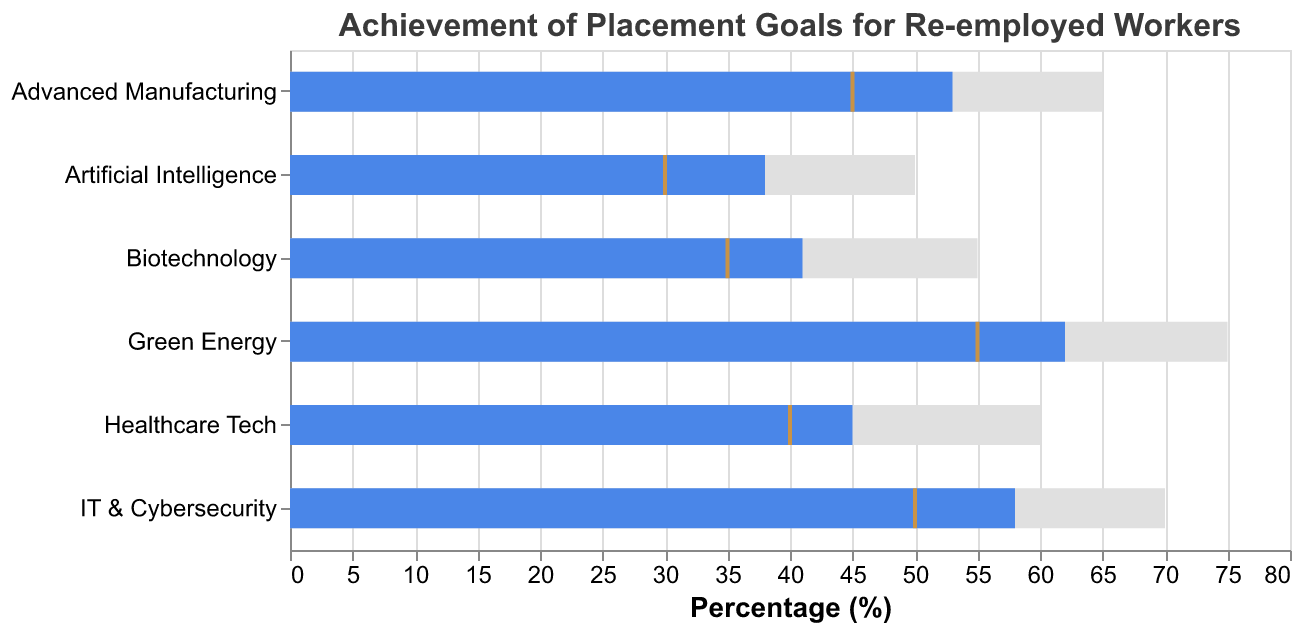By how many percent does the actual placement percentage for IT & Cybersecurity fall short of its target? Subtract the actual placement percentage from the target placement percentage for IT & Cybersecurity. Target is 70%, and Actual is 58%, so the shortfall is 70 - 58.
Answer: 12% What industries have met their benchmarks in placement goals? Industries that have their 'Actual' bars equal to or exceed the 'Benchmark' ticks meet their benchmarks.
Answer: Green Energy, IT & Cybersecurity, Advanced Manufacturing Which industry has the lowest benchmark placement percentage? Look for the industry with the lowest tick mark on the chart, which represents the benchmark.
Answer: Artificial Intelligence Compare the actual placement percentages of Advanced Manufacturing and Biotechnology. Which one is higher? Compare the lengths of the 'Actual' bars for both Advanced Manufacturing and Biotechnology.
Answer: Advanced Manufacturing What is the difference between the target and benchmark placement percentages for Artificial Intelligence? Subtract the benchmark percentage from the target percentage. Target is 50%, Benchmark is 30%, so the difference is 50 - 30.
Answer: 20% Which industries have exceeded their benchmark placement percentages but not reached their target percentages? Industries where the 'Actual' bar is higher than the benchmark tick but lower than the target bar are the ones.
Answer: Green Energy, IT & Cybersecurity, Advanced Manufacturing How many industries have an actual placement percentage less than 50%? Count the number of 'Actual' bars that are below the 50% mark.
Answer: 3 